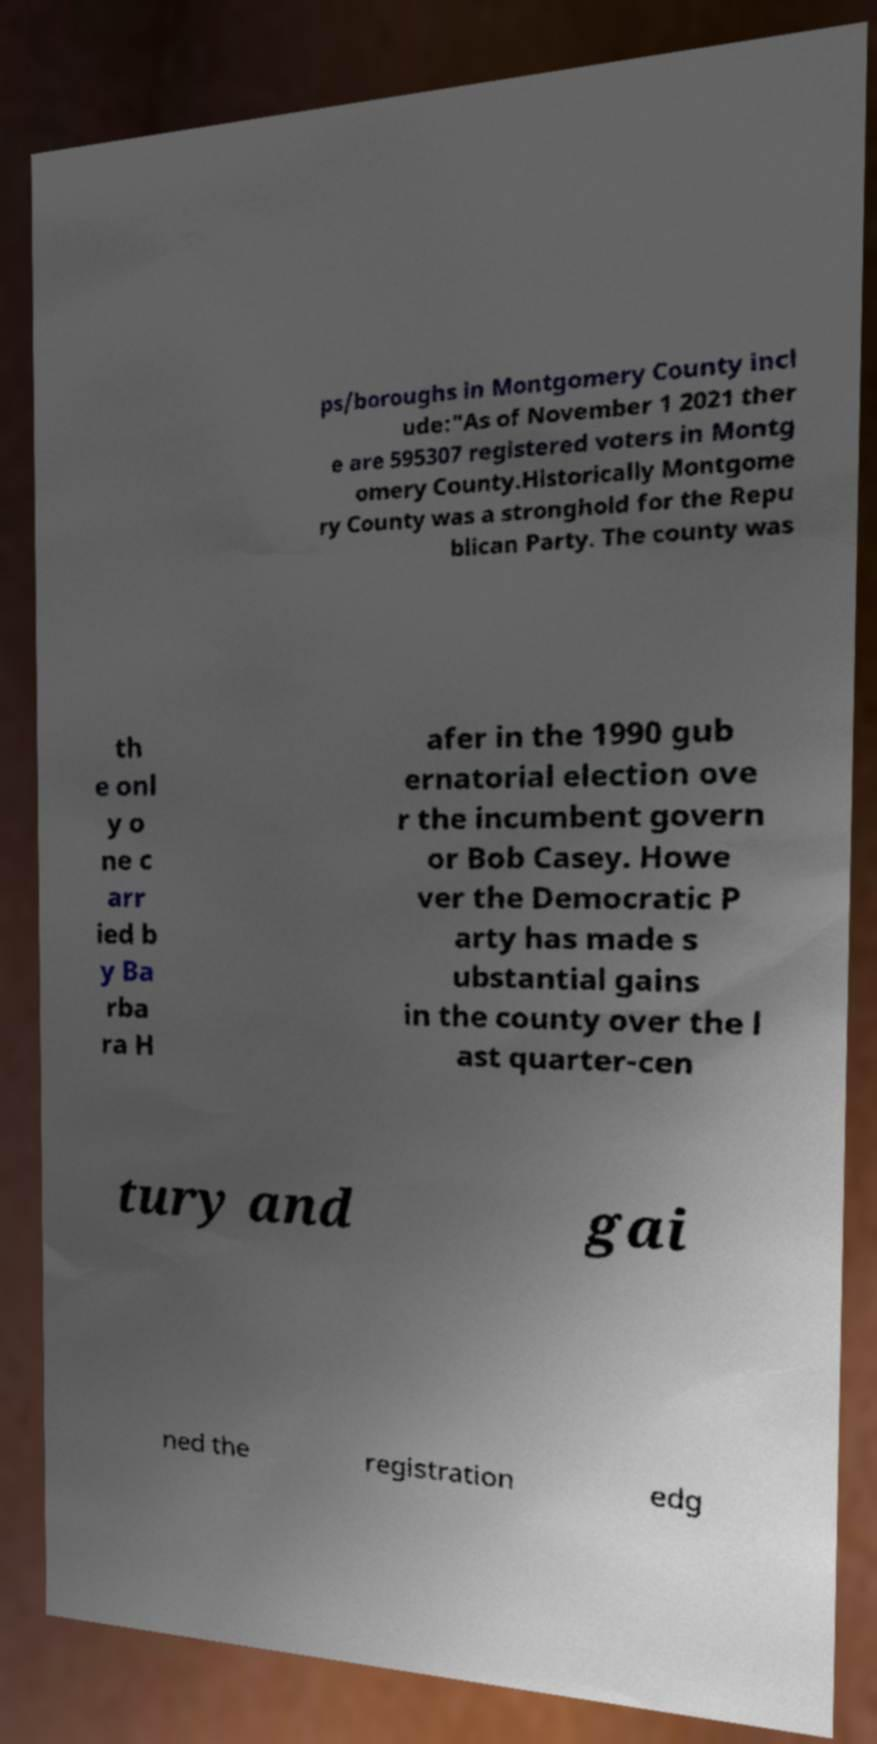Please identify and transcribe the text found in this image. ps/boroughs in Montgomery County incl ude:"As of November 1 2021 ther e are 595307 registered voters in Montg omery County.Historically Montgome ry County was a stronghold for the Repu blican Party. The county was th e onl y o ne c arr ied b y Ba rba ra H afer in the 1990 gub ernatorial election ove r the incumbent govern or Bob Casey. Howe ver the Democratic P arty has made s ubstantial gains in the county over the l ast quarter-cen tury and gai ned the registration edg 